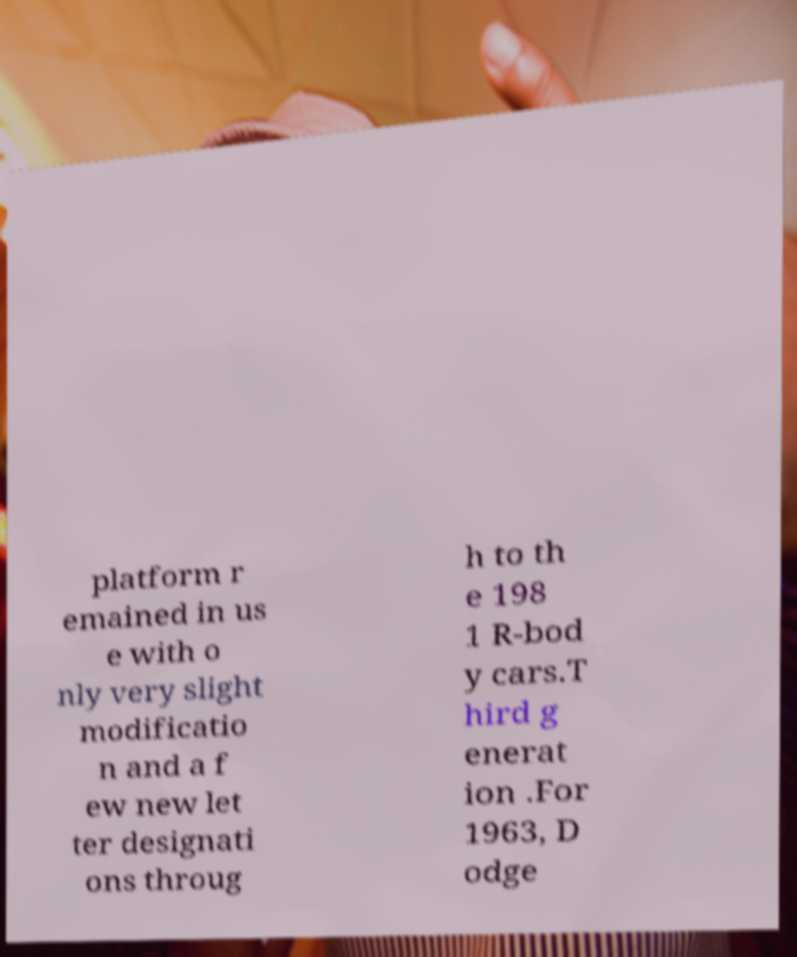I need the written content from this picture converted into text. Can you do that? platform r emained in us e with o nly very slight modificatio n and a f ew new let ter designati ons throug h to th e 198 1 R-bod y cars.T hird g enerat ion .For 1963, D odge 